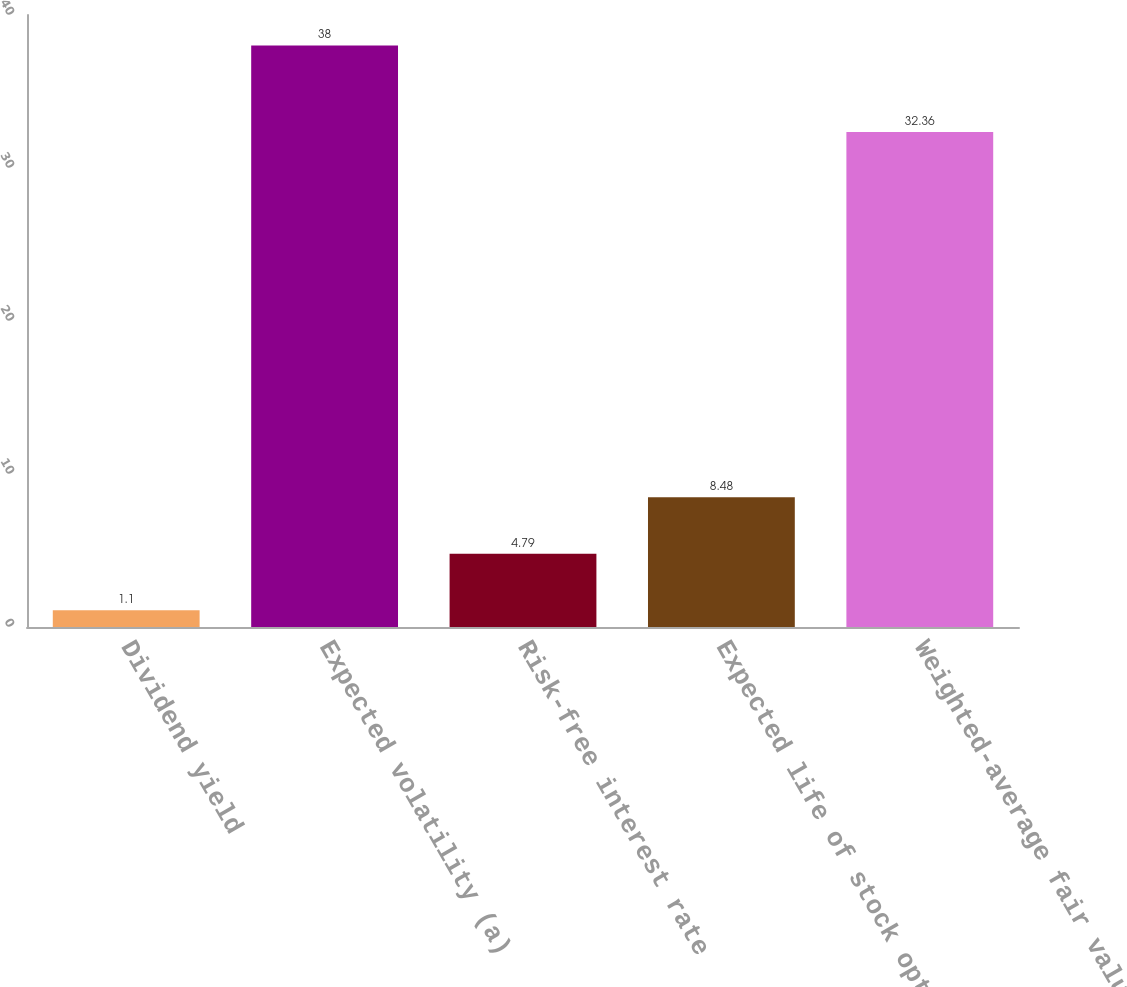Convert chart. <chart><loc_0><loc_0><loc_500><loc_500><bar_chart><fcel>Dividend yield<fcel>Expected volatility (a)<fcel>Risk-free interest rate<fcel>Expected life of stock option<fcel>Weighted-average fair value<nl><fcel>1.1<fcel>38<fcel>4.79<fcel>8.48<fcel>32.36<nl></chart> 